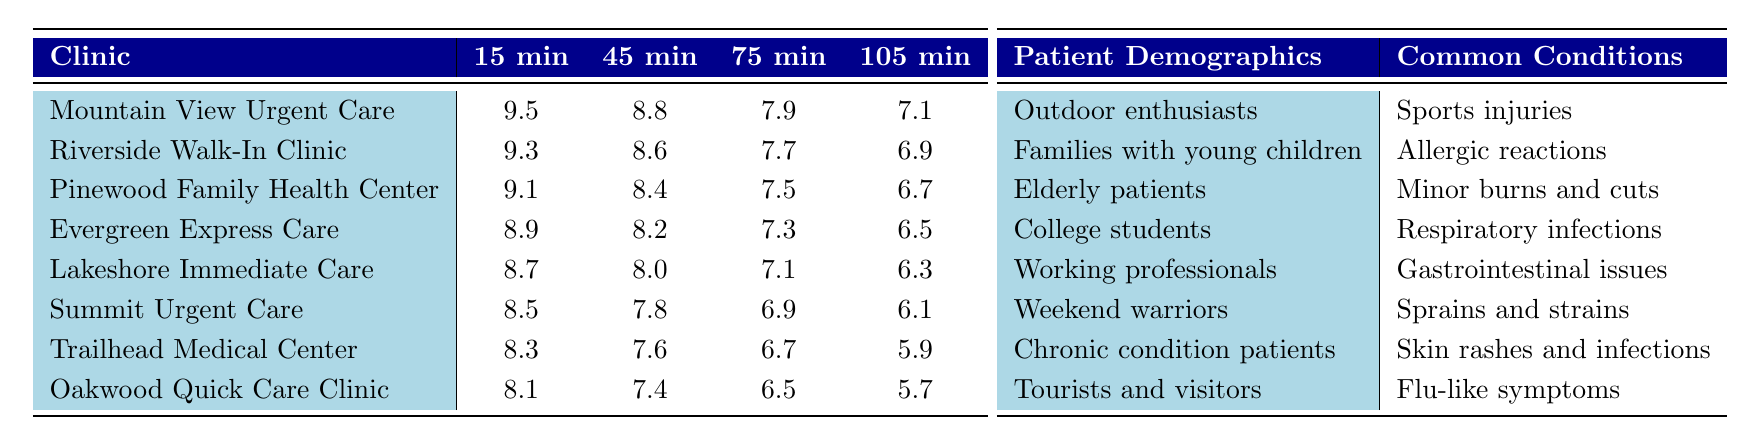What is the satisfaction score for Mountain View Urgent Care with a 15-minute wait? The table shows the satisfaction score for Mountain View Urgent Care with a 15-minute wait is 9.5.
Answer: 9.5 What is the wait time for the clinic with the lowest satisfaction score? The clinic with the lowest satisfaction score is Oakwood Quick Care Clinic, which has a wait time of 120 minutes.
Answer: 120 minutes Which clinic has a satisfaction score of 8.2 with a 60-minute wait? The table indicates that Evergreen Express Care has a satisfaction score of 8.2 with a 60-minute wait.
Answer: Evergreen Express Care What is the trend in satisfaction scores as wait times increase? As the wait times increase from 15 to 120 minutes, satisfaction scores consistently decrease for all clinics, indicating a negative correlation.
Answer: Negative correlation What is the average satisfaction score for Lakeshore Immediate Care across all wait times? The satisfaction scores for Lakeshore Immediate Care are 8.7, 8.0, 7.1, and 6.3. Summing these gives: 8.7 + 8.0 + 7.1 + 6.3 = 30.1. There are 4 scores, so the average is 30.1 / 4 = 7.525.
Answer: 7.525 Is the satisfaction score for Riverside Walk-In Clinic at a 90-minute wait higher or lower than that of Summit Urgent Care at a 75-minute wait? Riverside Walk-In Clinic has a satisfaction score of 7.3 at a 90-minute wait, while Summit Urgent Care has a score of 6.9 at a 75-minute wait. Since 7.3 is greater than 6.9, it is higher.
Answer: Higher Which clinic has the highest satisfaction score at a 45-minute wait? The highest satisfaction score at a 45-minute wait is from Mountain View Urgent Care, which scored 8.8.
Answer: Mountain View Urgent Care What is the difference between the highest and lowest satisfaction scores at a 105-minute wait? The highest score at a 105-minute wait is 7.1 (Mountain View Urgent Care) and the lowest is 5.9 (Trailhead Medical Center). The difference is 7.1 - 5.9 = 1.2.
Answer: 1.2 At which wait time do all clinics have a satisfaction score below 8.0? Looking at the scores, all clinics have a satisfaction score below 8.0 at a 105-minute wait (the highest being 7.1).
Answer: 105 minutes Which patient demographic is associated with chronic condition patients, and what is a common condition for this group? The patient demographic for chronic condition patients is defined as such, and a common condition for this group is skin rashes and infections.
Answer: Skin rashes and infections 